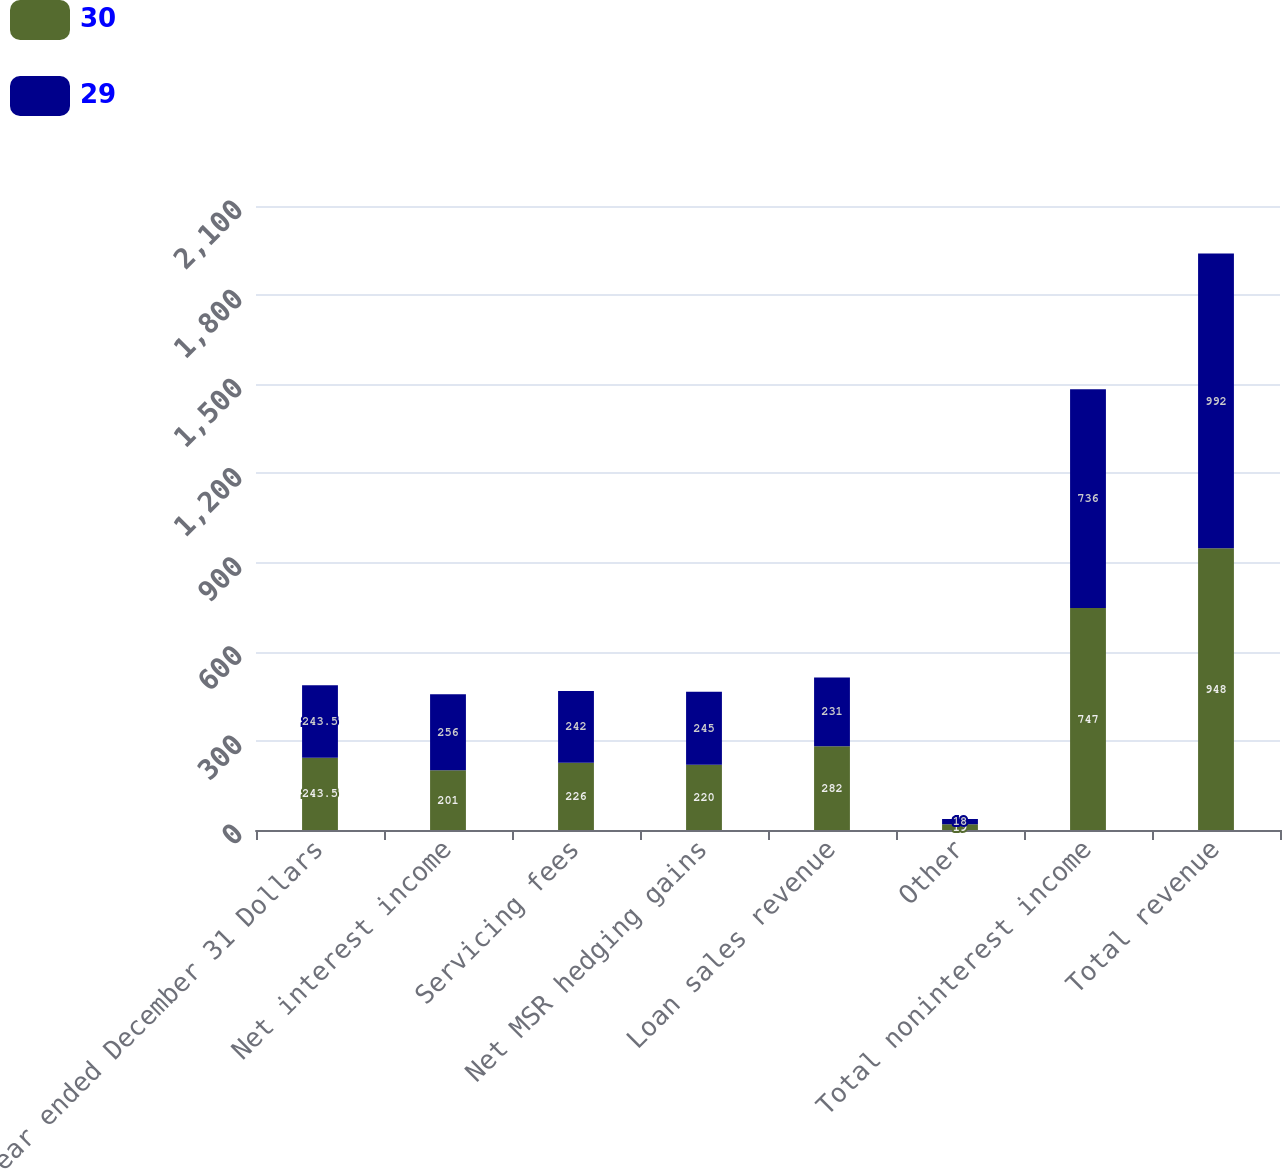<chart> <loc_0><loc_0><loc_500><loc_500><stacked_bar_chart><ecel><fcel>Year ended December 31 Dollars<fcel>Net interest income<fcel>Servicing fees<fcel>Net MSR hedging gains<fcel>Loan sales revenue<fcel>Other<fcel>Total noninterest income<fcel>Total revenue<nl><fcel>30<fcel>243.5<fcel>201<fcel>226<fcel>220<fcel>282<fcel>19<fcel>747<fcel>948<nl><fcel>29<fcel>243.5<fcel>256<fcel>242<fcel>245<fcel>231<fcel>18<fcel>736<fcel>992<nl></chart> 